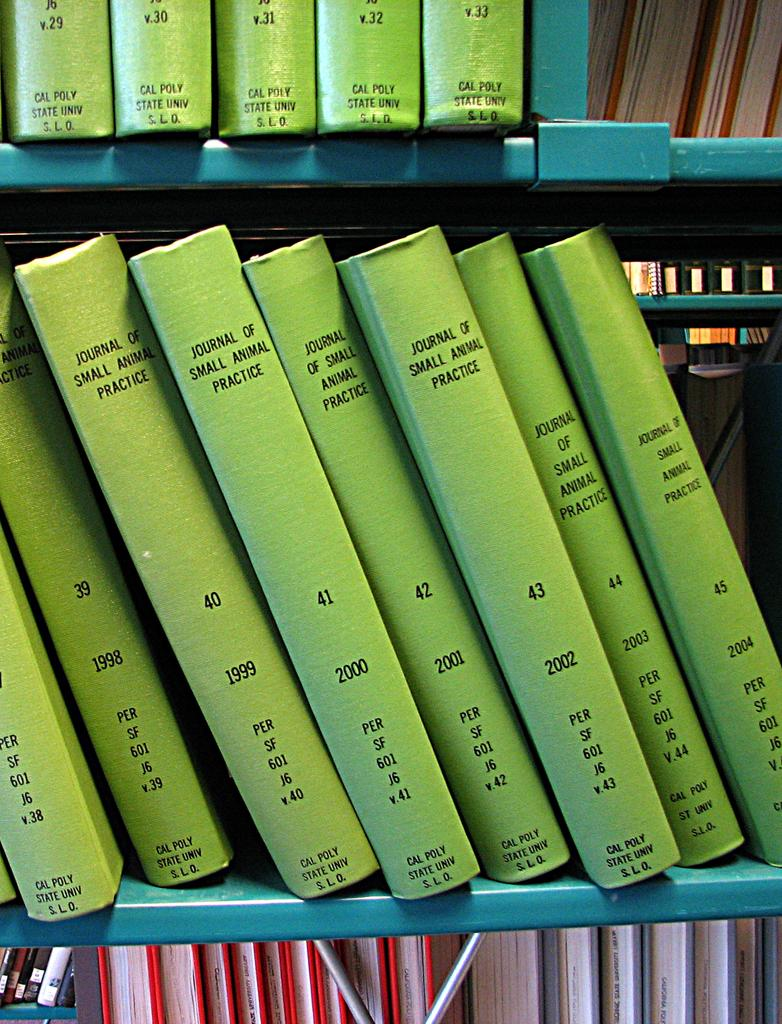<image>
Render a clear and concise summary of the photo. A row of journals for small animal practices. 